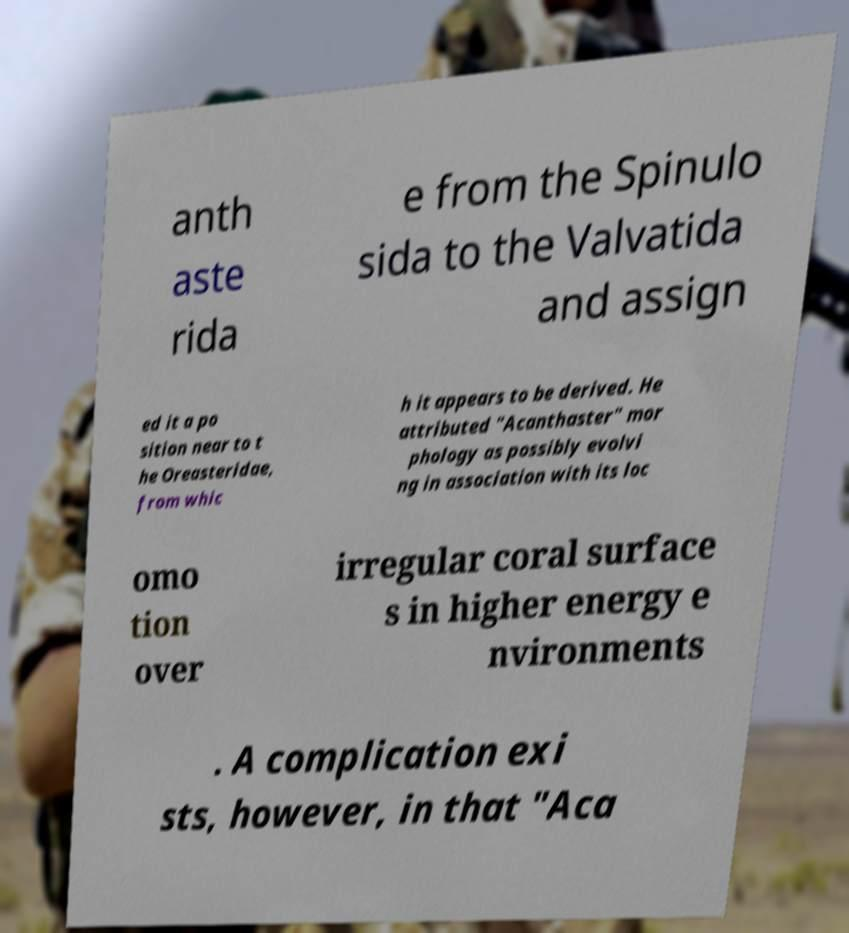What messages or text are displayed in this image? I need them in a readable, typed format. anth aste rida e from the Spinulo sida to the Valvatida and assign ed it a po sition near to t he Oreasteridae, from whic h it appears to be derived. He attributed "Acanthaster" mor phology as possibly evolvi ng in association with its loc omo tion over irregular coral surface s in higher energy e nvironments . A complication exi sts, however, in that "Aca 